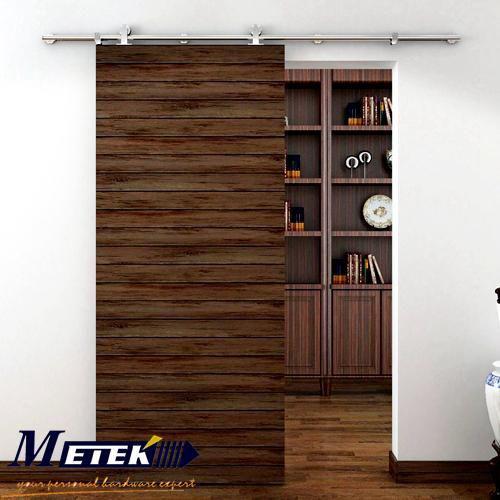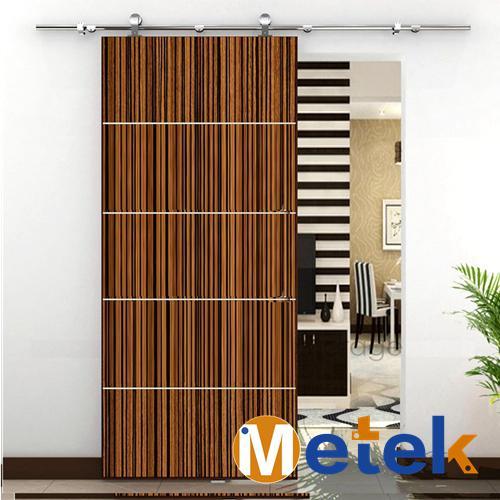The first image is the image on the left, the second image is the image on the right. Considering the images on both sides, is "In one image, the door has a horizontal strip wood grain pattern." valid? Answer yes or no. Yes. 